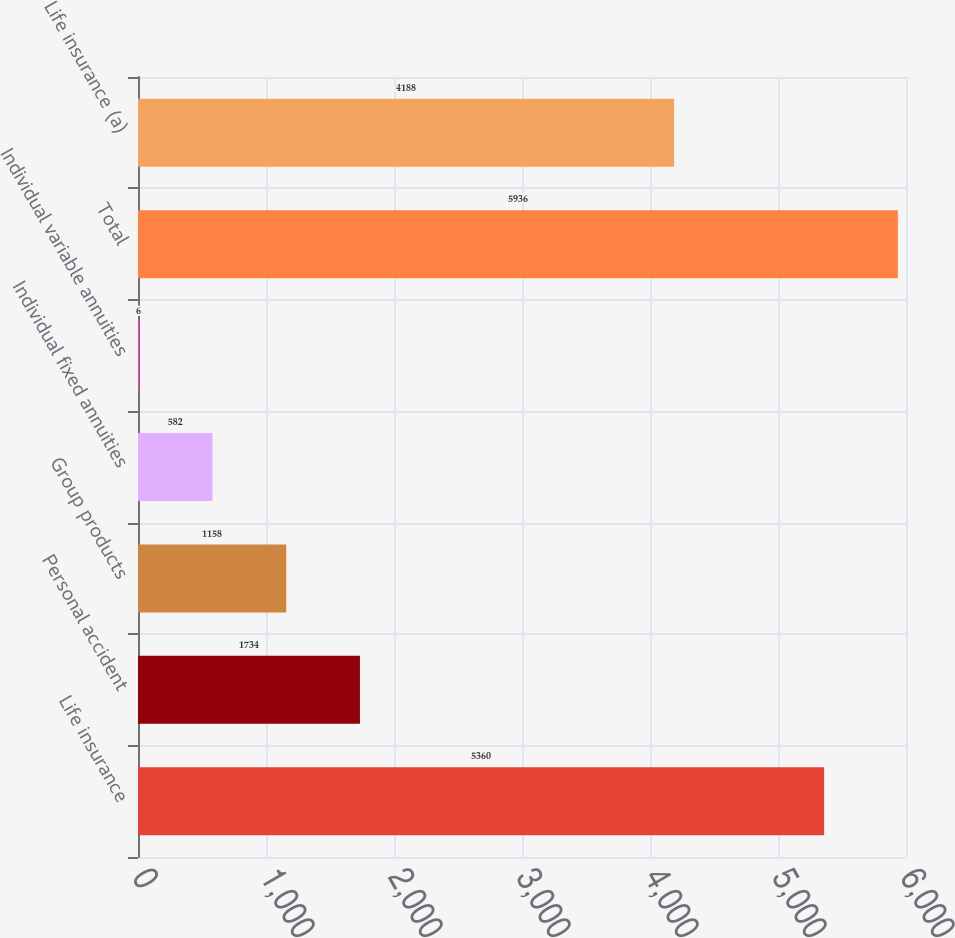<chart> <loc_0><loc_0><loc_500><loc_500><bar_chart><fcel>Life insurance<fcel>Personal accident<fcel>Group products<fcel>Individual fixed annuities<fcel>Individual variable annuities<fcel>Total<fcel>Life insurance (a)<nl><fcel>5360<fcel>1734<fcel>1158<fcel>582<fcel>6<fcel>5936<fcel>4188<nl></chart> 